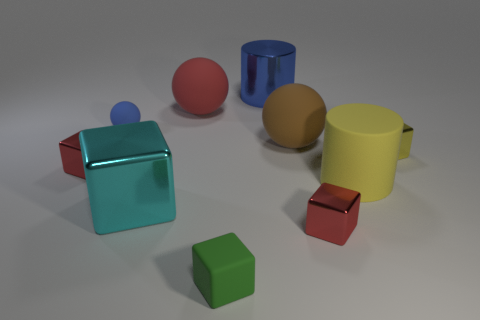Does the yellow object in front of the tiny yellow metal thing have the same size as the red metal block that is in front of the big yellow thing?
Offer a terse response. No. There is a thing that is both on the left side of the large cyan block and in front of the brown object; what is its material?
Keep it short and to the point. Metal. Is the number of red balls less than the number of small rubber objects?
Make the answer very short. Yes. There is a red block behind the red metal thing that is to the right of the large blue metal cylinder; what size is it?
Your response must be concise. Small. The small object that is behind the large matte ball on the right side of the large metal object that is behind the tiny matte sphere is what shape?
Your answer should be compact. Sphere. There is a large object that is made of the same material as the big cube; what is its color?
Offer a very short reply. Blue. What color is the small metallic object that is in front of the tiny block on the left side of the small matte object in front of the yellow metallic thing?
Provide a succinct answer. Red. What number of blocks are large gray metallic things or green objects?
Keep it short and to the point. 1. There is a thing that is the same color as the shiny cylinder; what is its material?
Ensure brevity in your answer.  Rubber. There is a tiny rubber ball; is its color the same as the metallic object behind the tiny yellow metallic cube?
Offer a very short reply. Yes. 